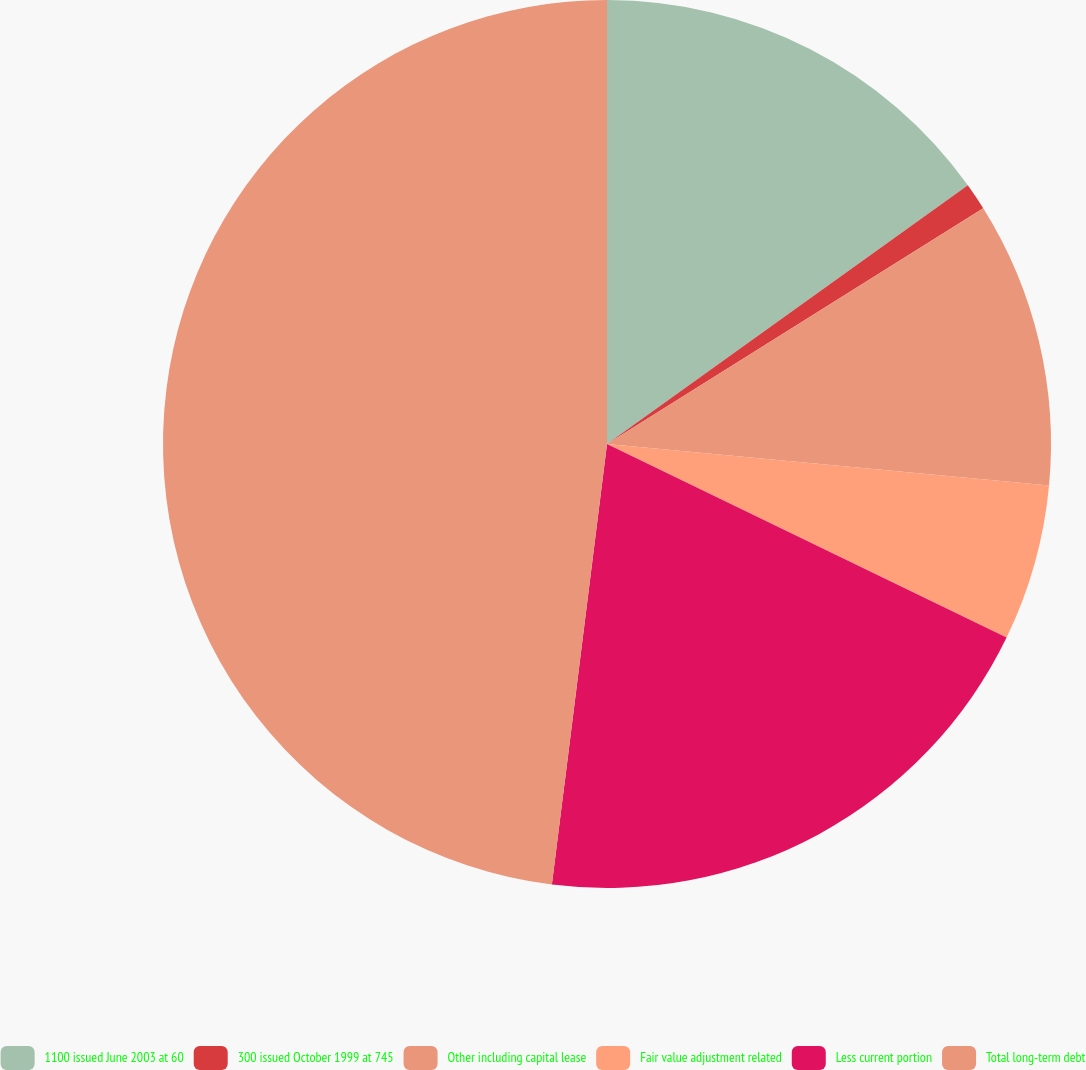Convert chart to OTSL. <chart><loc_0><loc_0><loc_500><loc_500><pie_chart><fcel>1100 issued June 2003 at 60<fcel>300 issued October 1999 at 745<fcel>Other including capital lease<fcel>Fair value adjustment related<fcel>Less current portion<fcel>Total long-term debt<nl><fcel>15.1%<fcel>0.99%<fcel>10.4%<fcel>5.69%<fcel>19.8%<fcel>48.02%<nl></chart> 